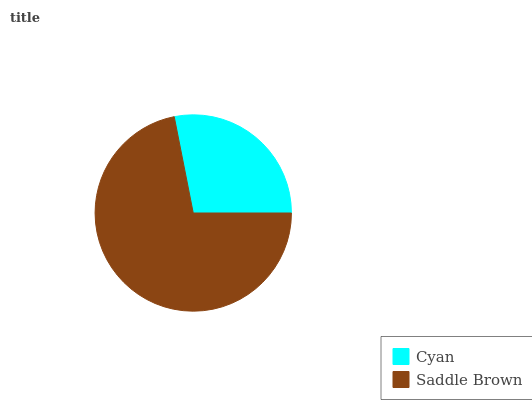Is Cyan the minimum?
Answer yes or no. Yes. Is Saddle Brown the maximum?
Answer yes or no. Yes. Is Saddle Brown the minimum?
Answer yes or no. No. Is Saddle Brown greater than Cyan?
Answer yes or no. Yes. Is Cyan less than Saddle Brown?
Answer yes or no. Yes. Is Cyan greater than Saddle Brown?
Answer yes or no. No. Is Saddle Brown less than Cyan?
Answer yes or no. No. Is Saddle Brown the high median?
Answer yes or no. Yes. Is Cyan the low median?
Answer yes or no. Yes. Is Cyan the high median?
Answer yes or no. No. Is Saddle Brown the low median?
Answer yes or no. No. 